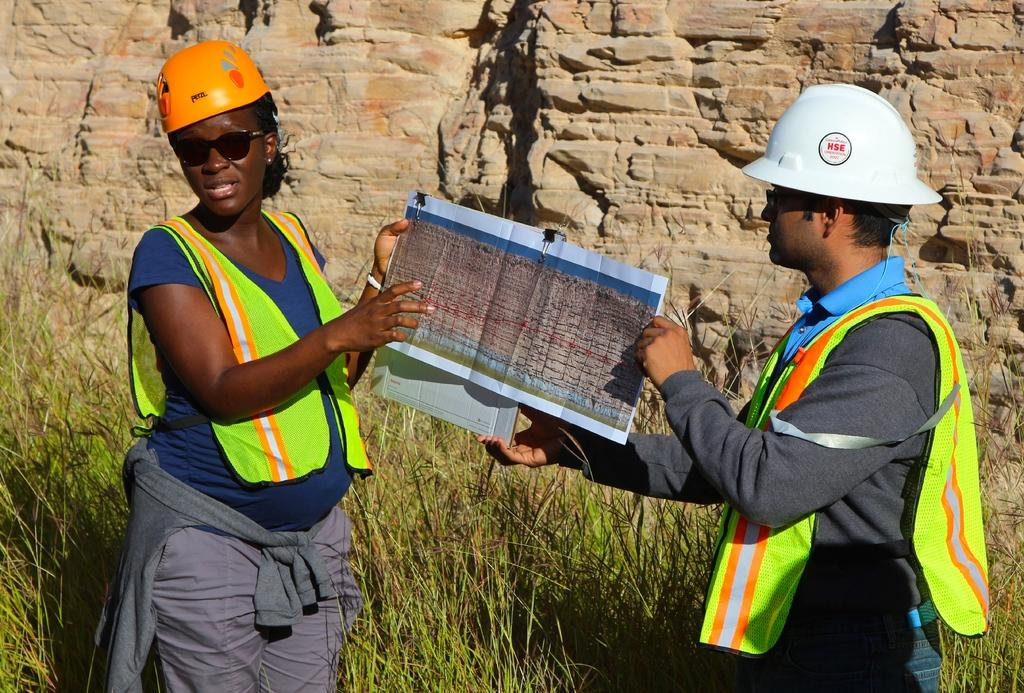How many people are in the image? There are two persons in the image. What are the two persons holding in the image? The two persons are holding paper. What type of natural elements can be seen in the image? There are plants and rocks in the image. What type of plastic bag can be seen in the image? There is no plastic bag present in the image. What kind of truck is visible in the image? There is no truck visible in the image. 